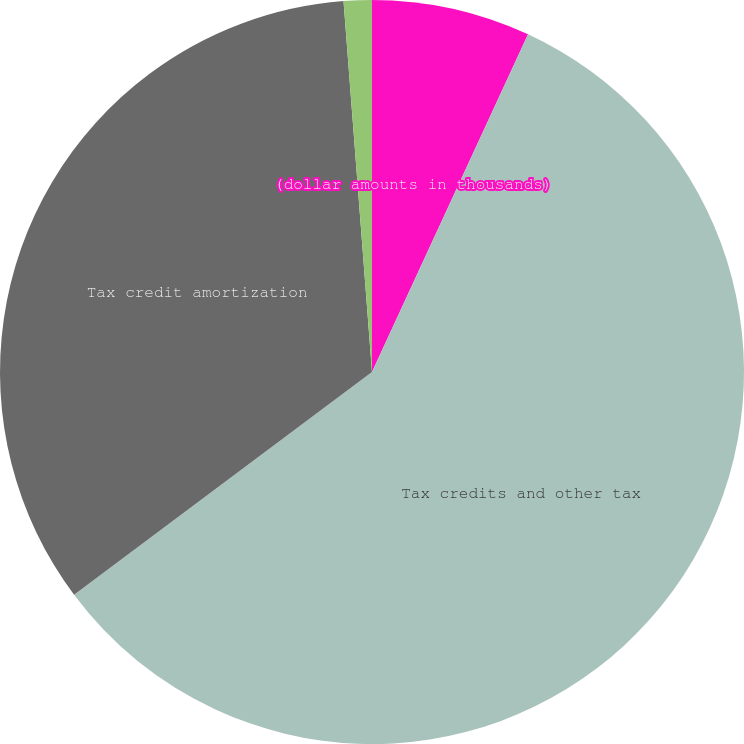<chart> <loc_0><loc_0><loc_500><loc_500><pie_chart><fcel>(dollar amounts in thousands)<fcel>Tax credits and other tax<fcel>Tax credit amortization<fcel>Tax credit investment losses<nl><fcel>6.89%<fcel>57.89%<fcel>34.0%<fcel>1.22%<nl></chart> 